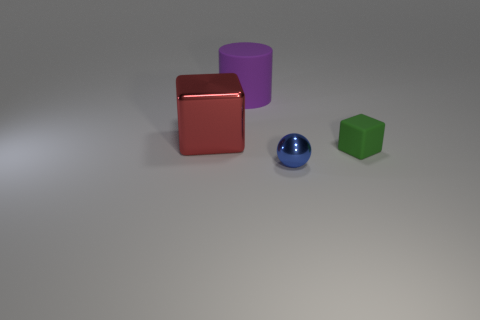Are there an equal number of small blocks that are on the right side of the tiny green cube and small rubber blocks in front of the large rubber cylinder?
Make the answer very short. No. What is the shape of the shiny thing that is in front of the thing that is right of the shiny thing that is on the right side of the red shiny thing?
Give a very brief answer. Sphere. Is the large object that is behind the big red metal thing made of the same material as the cube that is in front of the big metallic object?
Give a very brief answer. Yes. What shape is the large object in front of the large rubber cylinder?
Offer a terse response. Cube. Are there fewer large cylinders than tiny blue blocks?
Provide a succinct answer. No. Are there any big purple cylinders in front of the rubber thing that is to the left of the metal object in front of the small rubber thing?
Make the answer very short. No. What number of rubber things are purple things or blocks?
Give a very brief answer. 2. Do the cylinder and the big metal block have the same color?
Provide a short and direct response. No. What number of tiny blue balls are behind the small matte cube?
Give a very brief answer. 0. What number of things are in front of the tiny matte cube and behind the red cube?
Your answer should be compact. 0. 